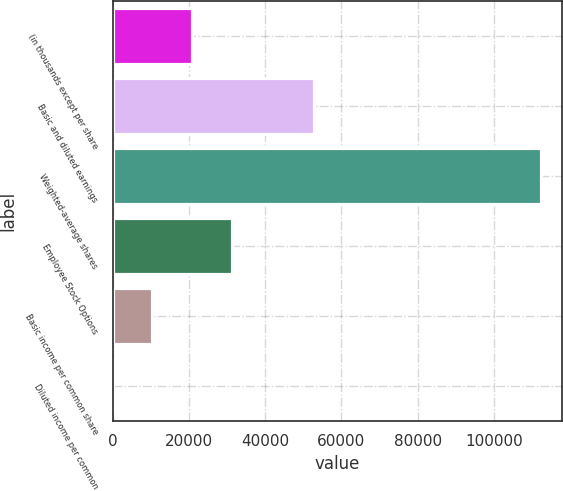<chart> <loc_0><loc_0><loc_500><loc_500><bar_chart><fcel>(in thousands except per share<fcel>Basic and diluted earnings<fcel>Weighted-average shares<fcel>Employee Stock Options<fcel>Basic income per common share<fcel>Diluted income per common<nl><fcel>20932<fcel>52773<fcel>112313<fcel>31397.8<fcel>10466.3<fcel>0.51<nl></chart> 